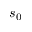Convert formula to latex. <formula><loc_0><loc_0><loc_500><loc_500>s _ { 0 }</formula> 